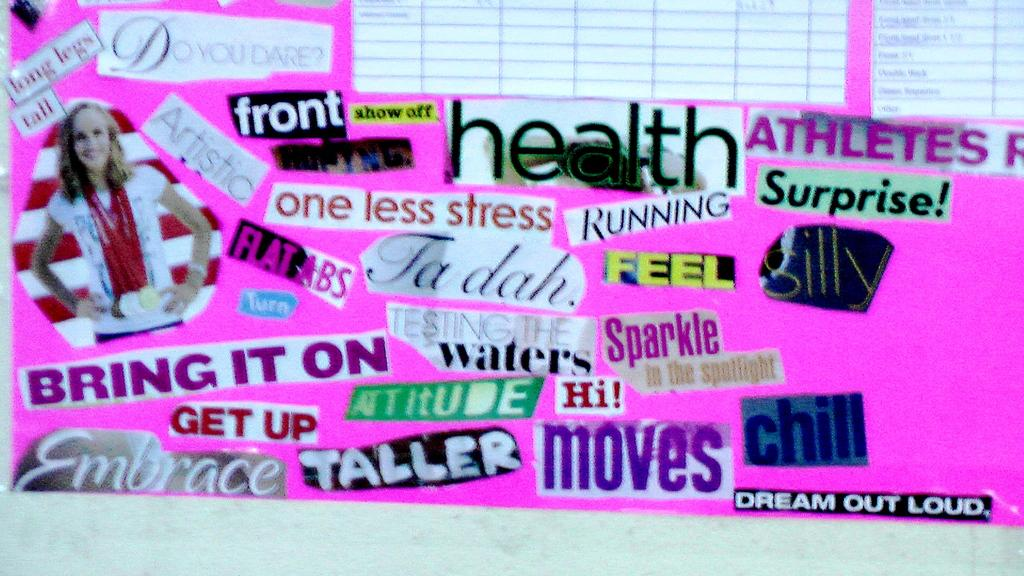What is the main subject of the image? The main subject of the image is a chart. What can be seen on the chart? The chart has various stickers on it. What color is the chart? The chart is in pink color. Is there any liquid visible on the chart in the image? No, there is no liquid visible on the chart in the image. Is the chart hot to the touch in the image? The facts provided do not mention the temperature of the chart, but it is not mentioned as being hot. 